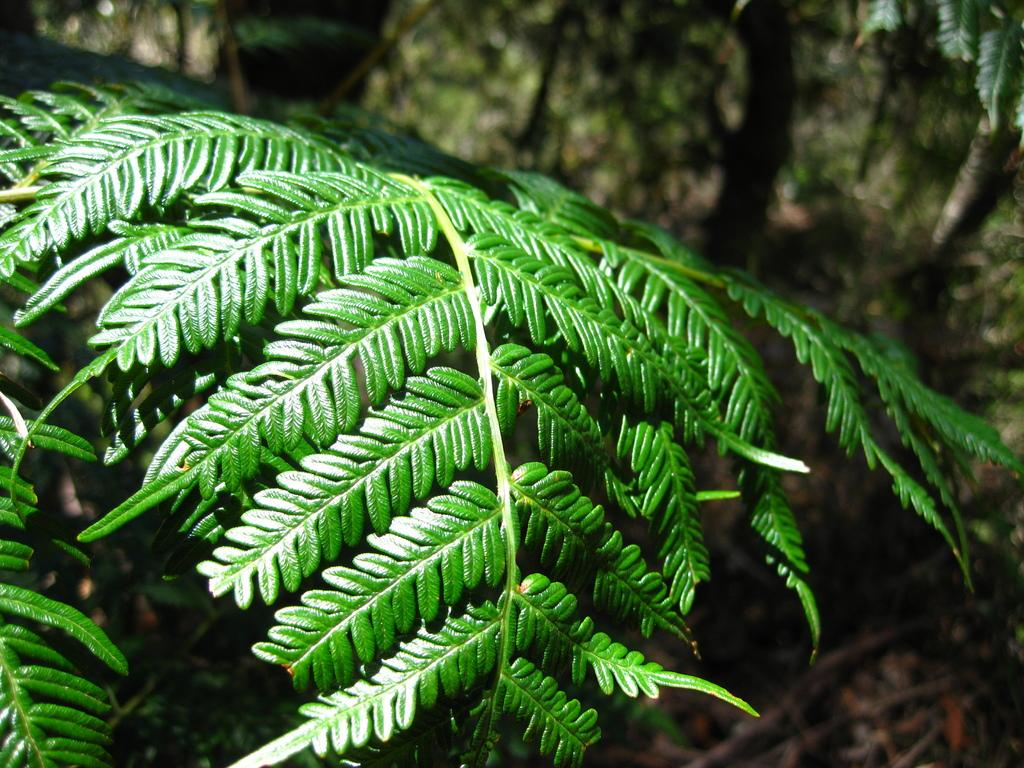What type of vegetation is visible in the front of the image? There are leaves in the front of the image. What can be observed about the background of the image? The background of the image is blurry. What time of day is the judge expected to arrive in the image? There is no judge present in the image, and therefore no time of day can be associated with their arrival. 